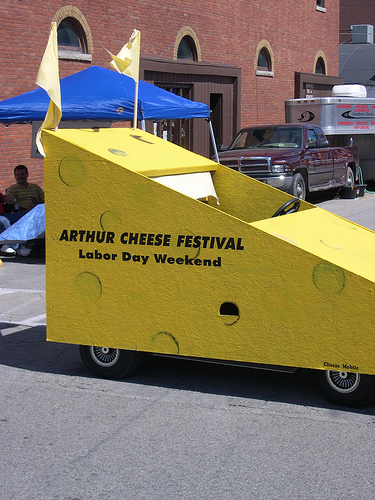<image>
Is the car behind the window? No. The car is not behind the window. From this viewpoint, the car appears to be positioned elsewhere in the scene. 